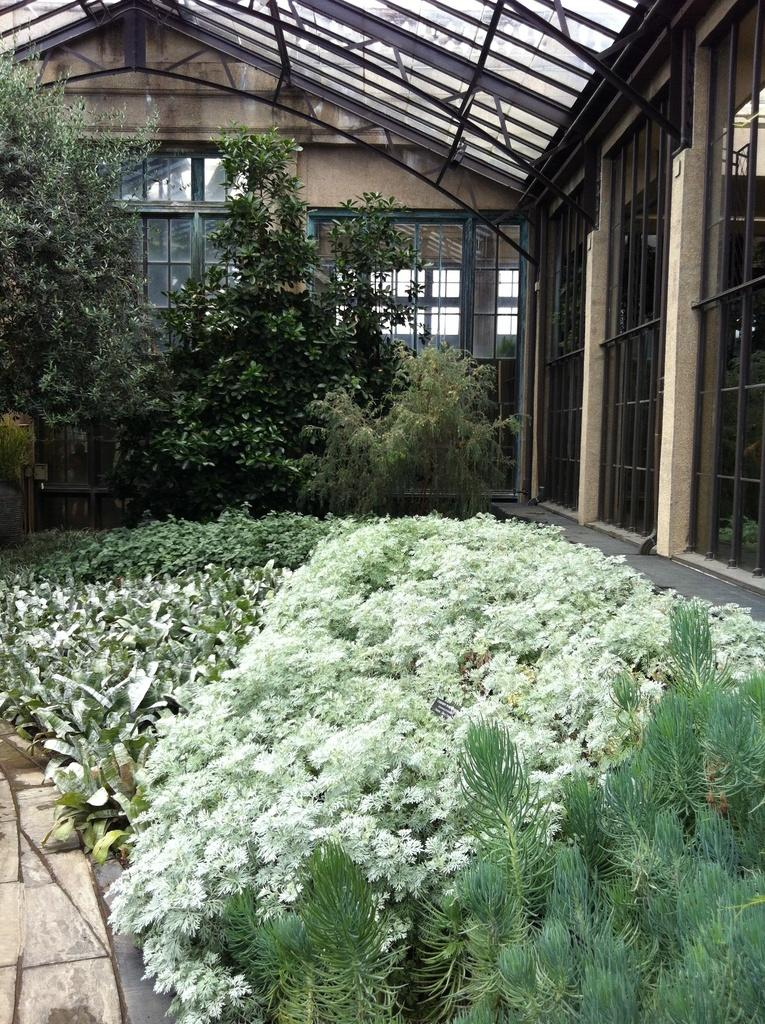What type of vegetation is present at the bottom of the image? There are many plants at the bottom of the image. What can be seen on the right side of the image? There is a glass on the right side of the image. What is visible in the background of the image? There are trees and a building in the background of the image. How many lizards are crawling on the glass in the image? There are no lizards present in the image. What is the army doing in the background of the image? There is no army present in the image. 